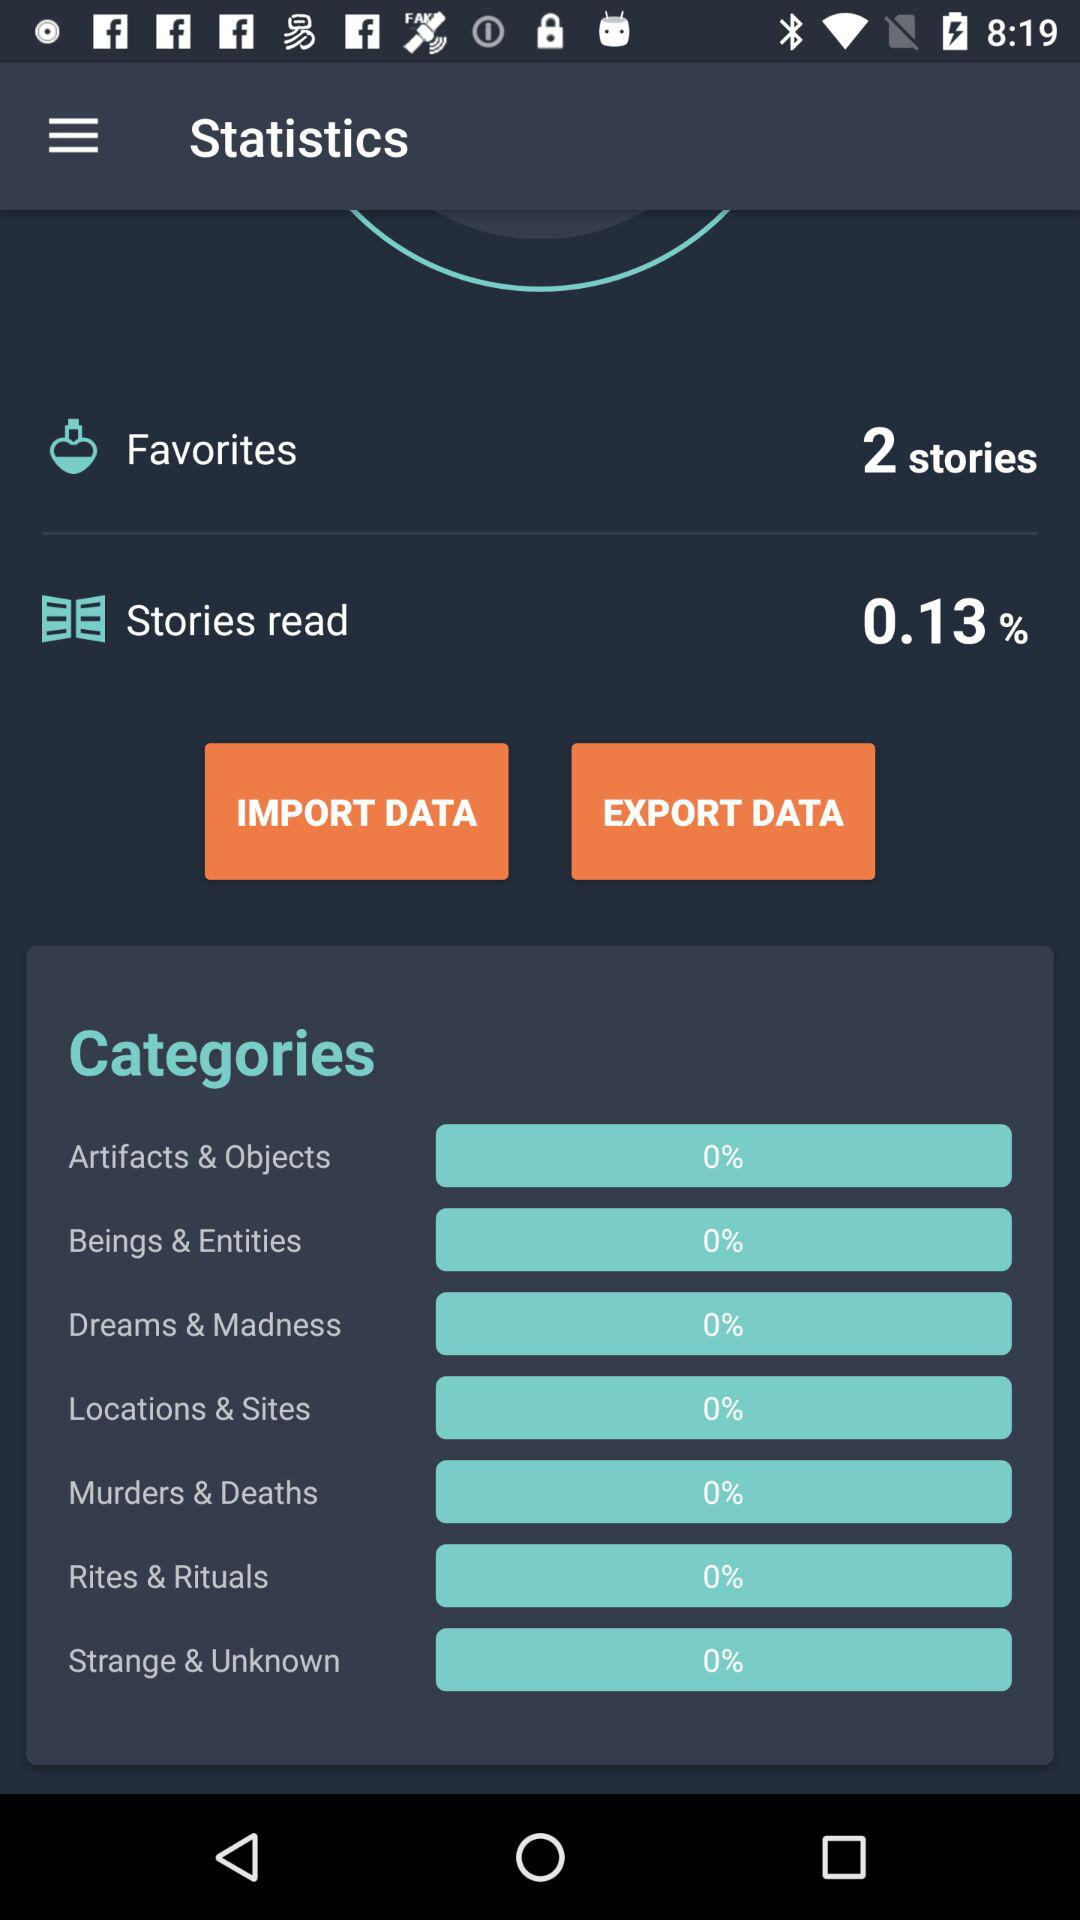How many stories does the "Favorites" section contain? The "Favorites" section contains 2 stories. 